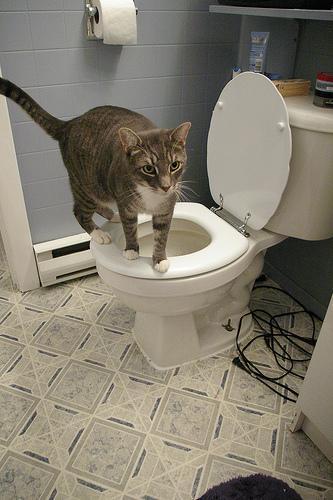How many toilets in the photo?
Give a very brief answer. 1. 